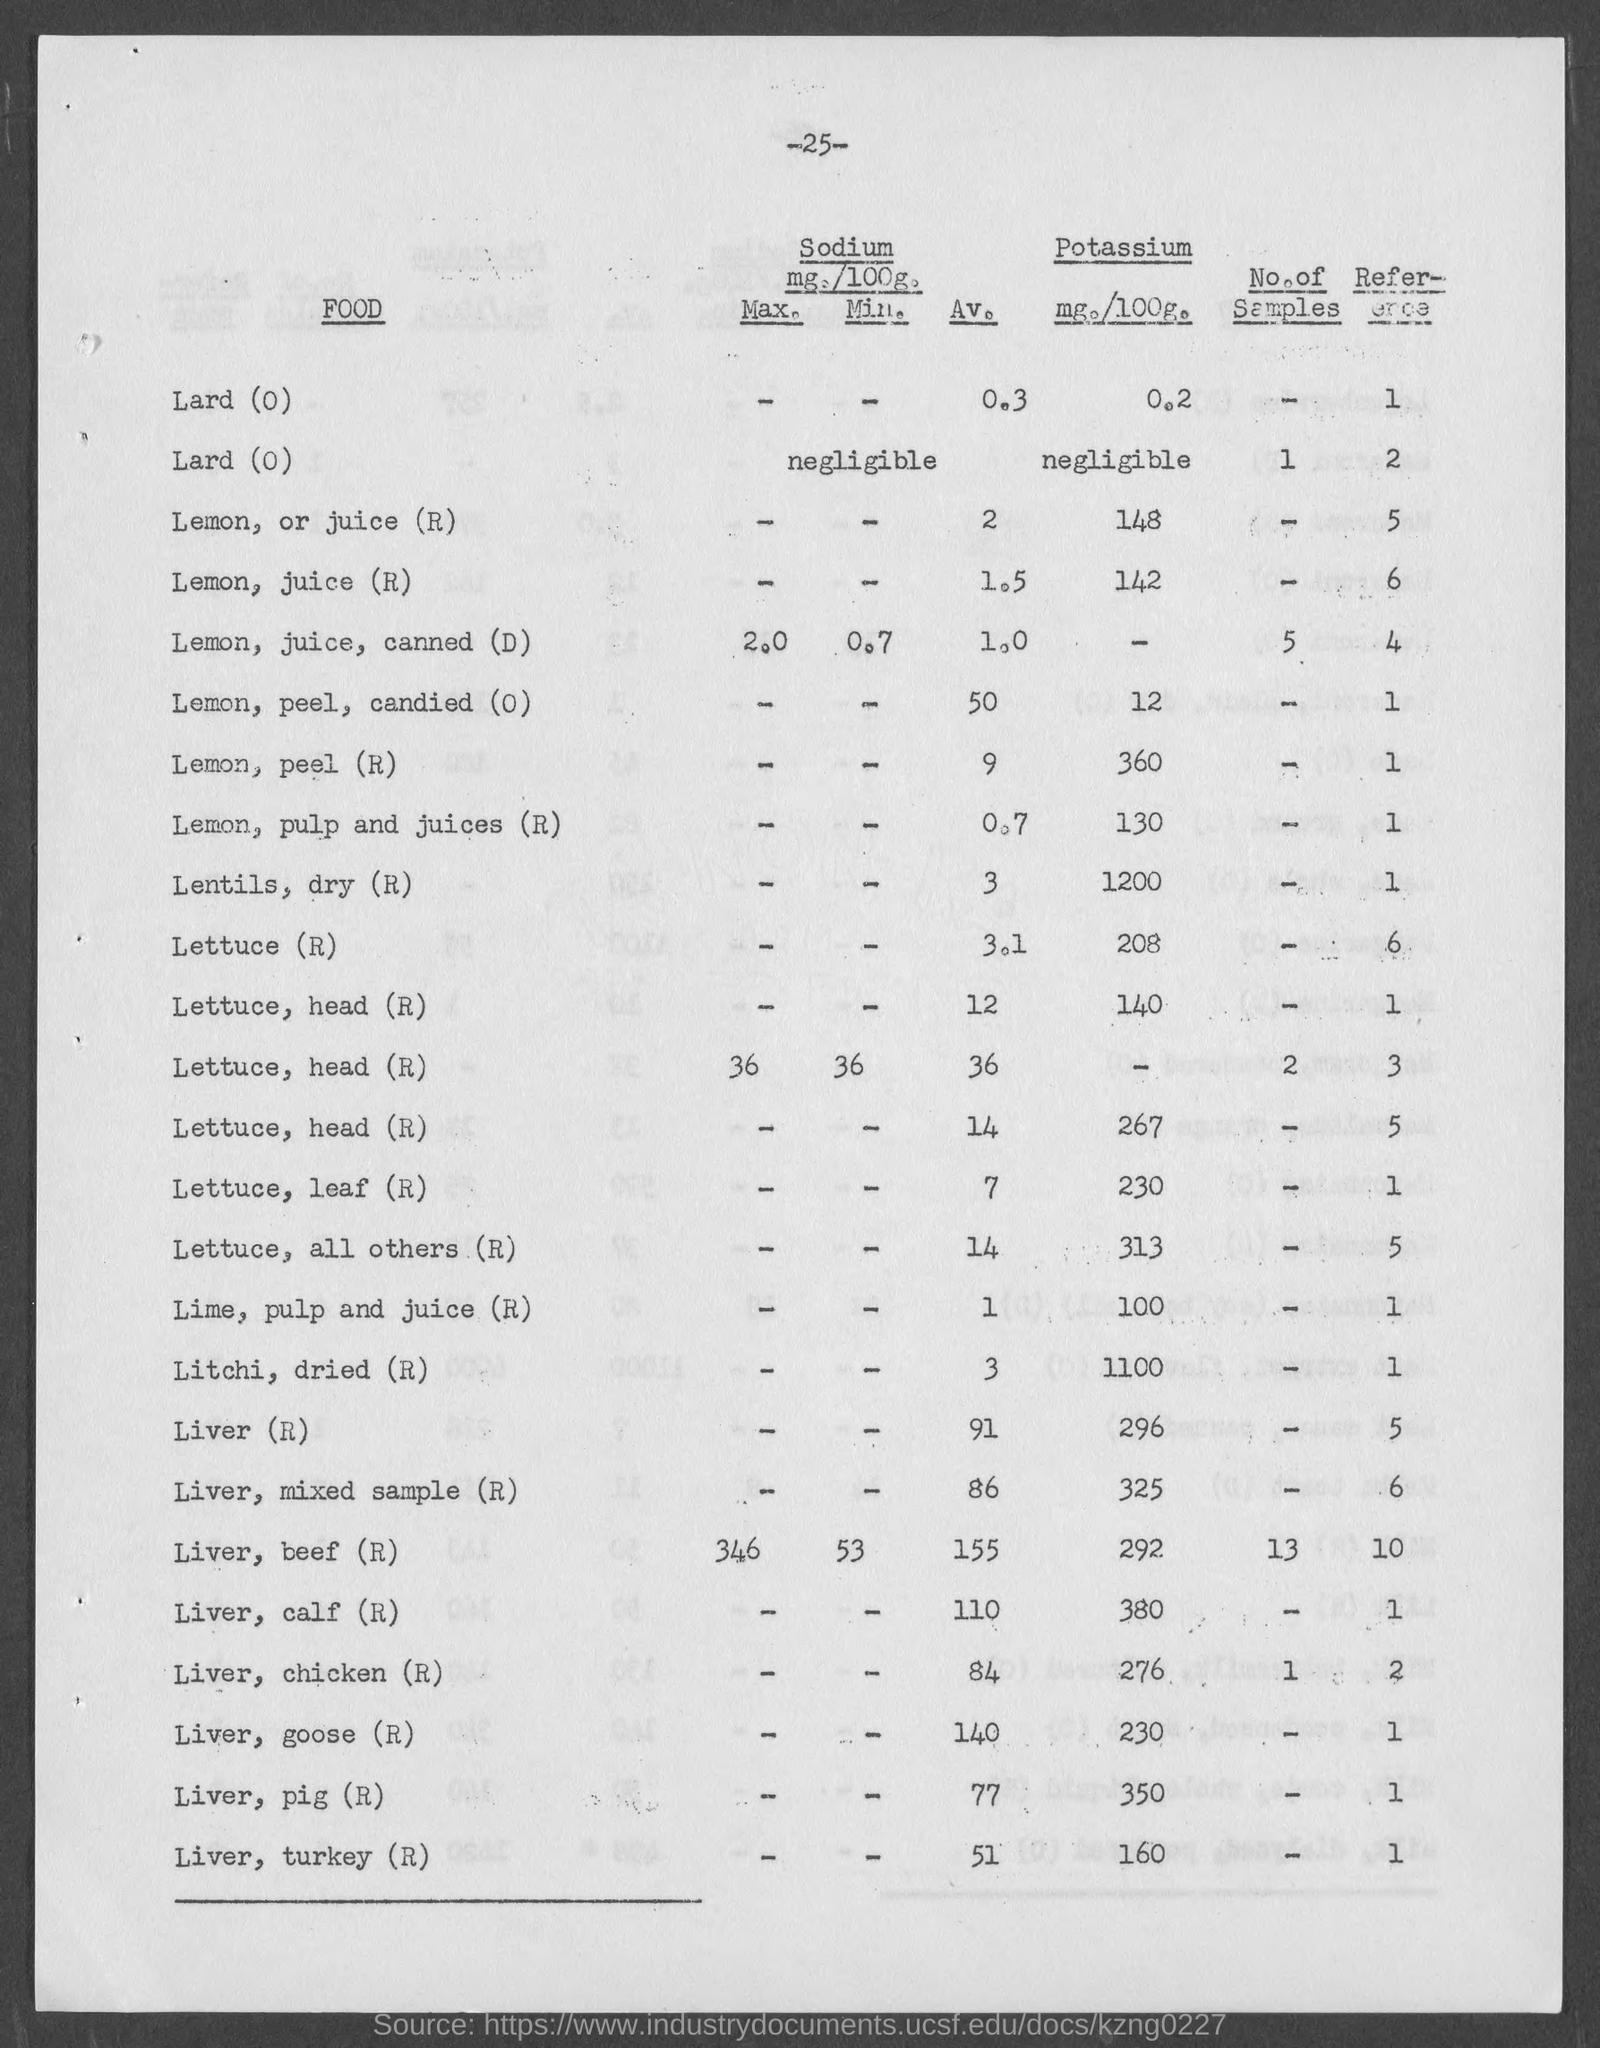What is the amount of potassium present in lemon , or juice(r) as mentioned in the given page ?
Give a very brief answer. 148. What is the amount of potassium present in lemon , peel(r) as mentioned in the given page ?
Ensure brevity in your answer.  360. What is the amount of potassium present in lettuce(r) as mentioned in the given page ?
Ensure brevity in your answer.  208. What is the av. value of sodium in lemon , or juice (r) as mentioned in the given page ?
Give a very brief answer. 2. What is the amount of potassium present in lentils, dry(r) as mentioned in the given page ?
Your response must be concise. 1200. What is the av. value of sodium in liver (r) as mentioned in the given page ?
Provide a succinct answer. 91. What is the amount of potassium present in liver (r) as mentioned in the given page ?
Offer a very short reply. 296. What is the av. value of sodium in lettuce (r) as mentioned in the given page ?
Your answer should be compact. 3.1. 